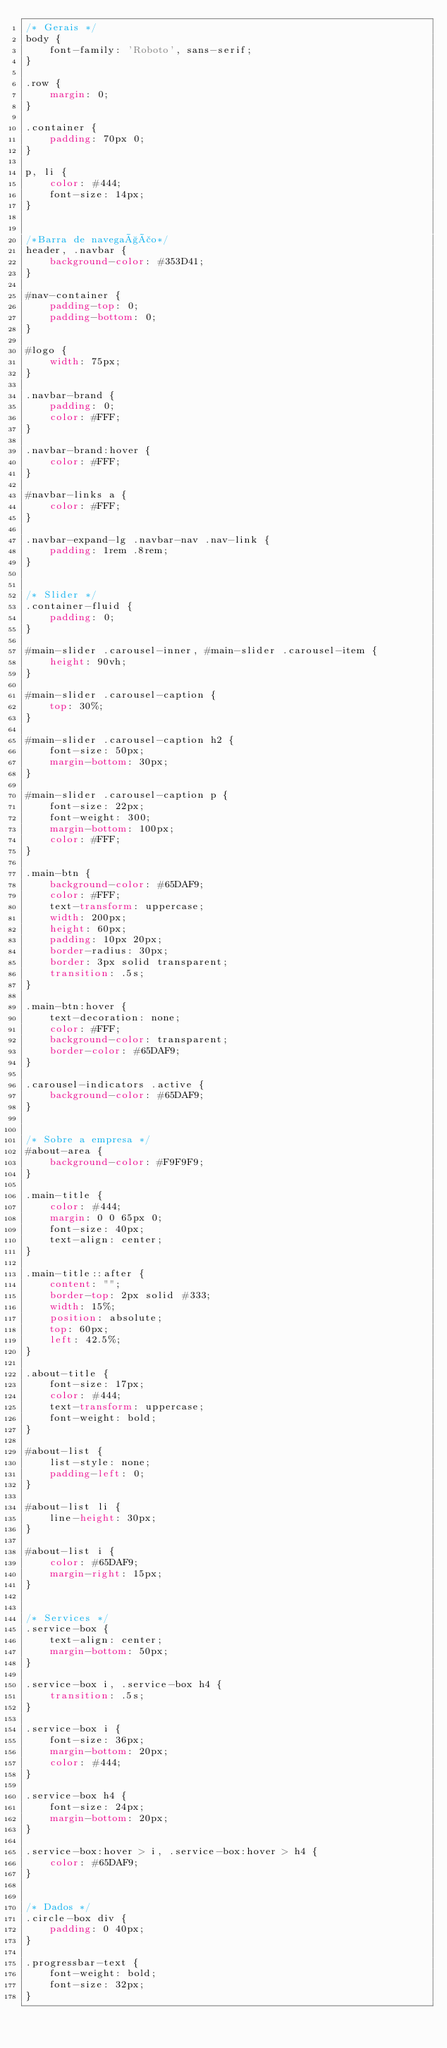<code> <loc_0><loc_0><loc_500><loc_500><_CSS_>/* Gerais */
body {
    font-family: 'Roboto', sans-serif;
}

.row {
    margin: 0;
}

.container {
    padding: 70px 0;
}

p, li {
    color: #444;
    font-size: 14px;
}


/*Barra de navegação*/
header, .navbar {
    background-color: #353D41;
}

#nav-container {
    padding-top: 0;
    padding-bottom: 0;
}

#logo {
    width: 75px;
}

.navbar-brand {
    padding: 0;
    color: #FFF;
}

.navbar-brand:hover {
    color: #FFF;
}

#navbar-links a {
    color: #FFF;
}

.navbar-expand-lg .navbar-nav .nav-link {
    padding: 1rem .8rem;
}


/* Slider */
.container-fluid {
    padding: 0;
}

#main-slider .carousel-inner, #main-slider .carousel-item {
    height: 90vh;
}

#main-slider .carousel-caption {
    top: 30%;
}

#main-slider .carousel-caption h2 {
    font-size: 50px;
    margin-bottom: 30px;
}

#main-slider .carousel-caption p {
    font-size: 22px;
    font-weight: 300;
    margin-bottom: 100px;
    color: #FFF;
}

.main-btn {
    background-color: #65DAF9;
    color: #FFF;
    text-transform: uppercase;
    width: 200px;
    height: 60px;
    padding: 10px 20px;
    border-radius: 30px;
    border: 3px solid transparent;
    transition: .5s;
}

.main-btn:hover {
    text-decoration: none;
    color: #FFF;
    background-color: transparent;
    border-color: #65DAF9;
}

.carousel-indicators .active {
    background-color: #65DAF9;
}


/* Sobre a empresa */
#about-area {
    background-color: #F9F9F9;
}

.main-title {
    color: #444;
    margin: 0 0 65px 0;
    font-size: 40px;
    text-align: center;
}

.main-title::after {
    content: "";
    border-top: 2px solid #333;
    width: 15%;
    position: absolute;
    top: 60px;
    left: 42.5%;
}

.about-title {
    font-size: 17px;
    color: #444;
    text-transform: uppercase;
    font-weight: bold;
}

#about-list {
    list-style: none;
    padding-left: 0;
}

#about-list li {
    line-height: 30px;
}

#about-list i {
    color: #65DAF9;
    margin-right: 15px;
}


/* Services */
.service-box {
    text-align: center;
    margin-bottom: 50px;
}

.service-box i, .service-box h4 {
    transition: .5s;
}

.service-box i {
    font-size: 36px;
    margin-bottom: 20px;
    color: #444;
}

.service-box h4 {
    font-size: 24px;
    margin-bottom: 20px;
}

.service-box:hover > i, .service-box:hover > h4 {
    color: #65DAF9;
}


/* Dados */
.circle-box div {
    padding: 0 40px;
}

.progressbar-text {
    font-weight: bold;
    font-size: 32px;
}
</code> 